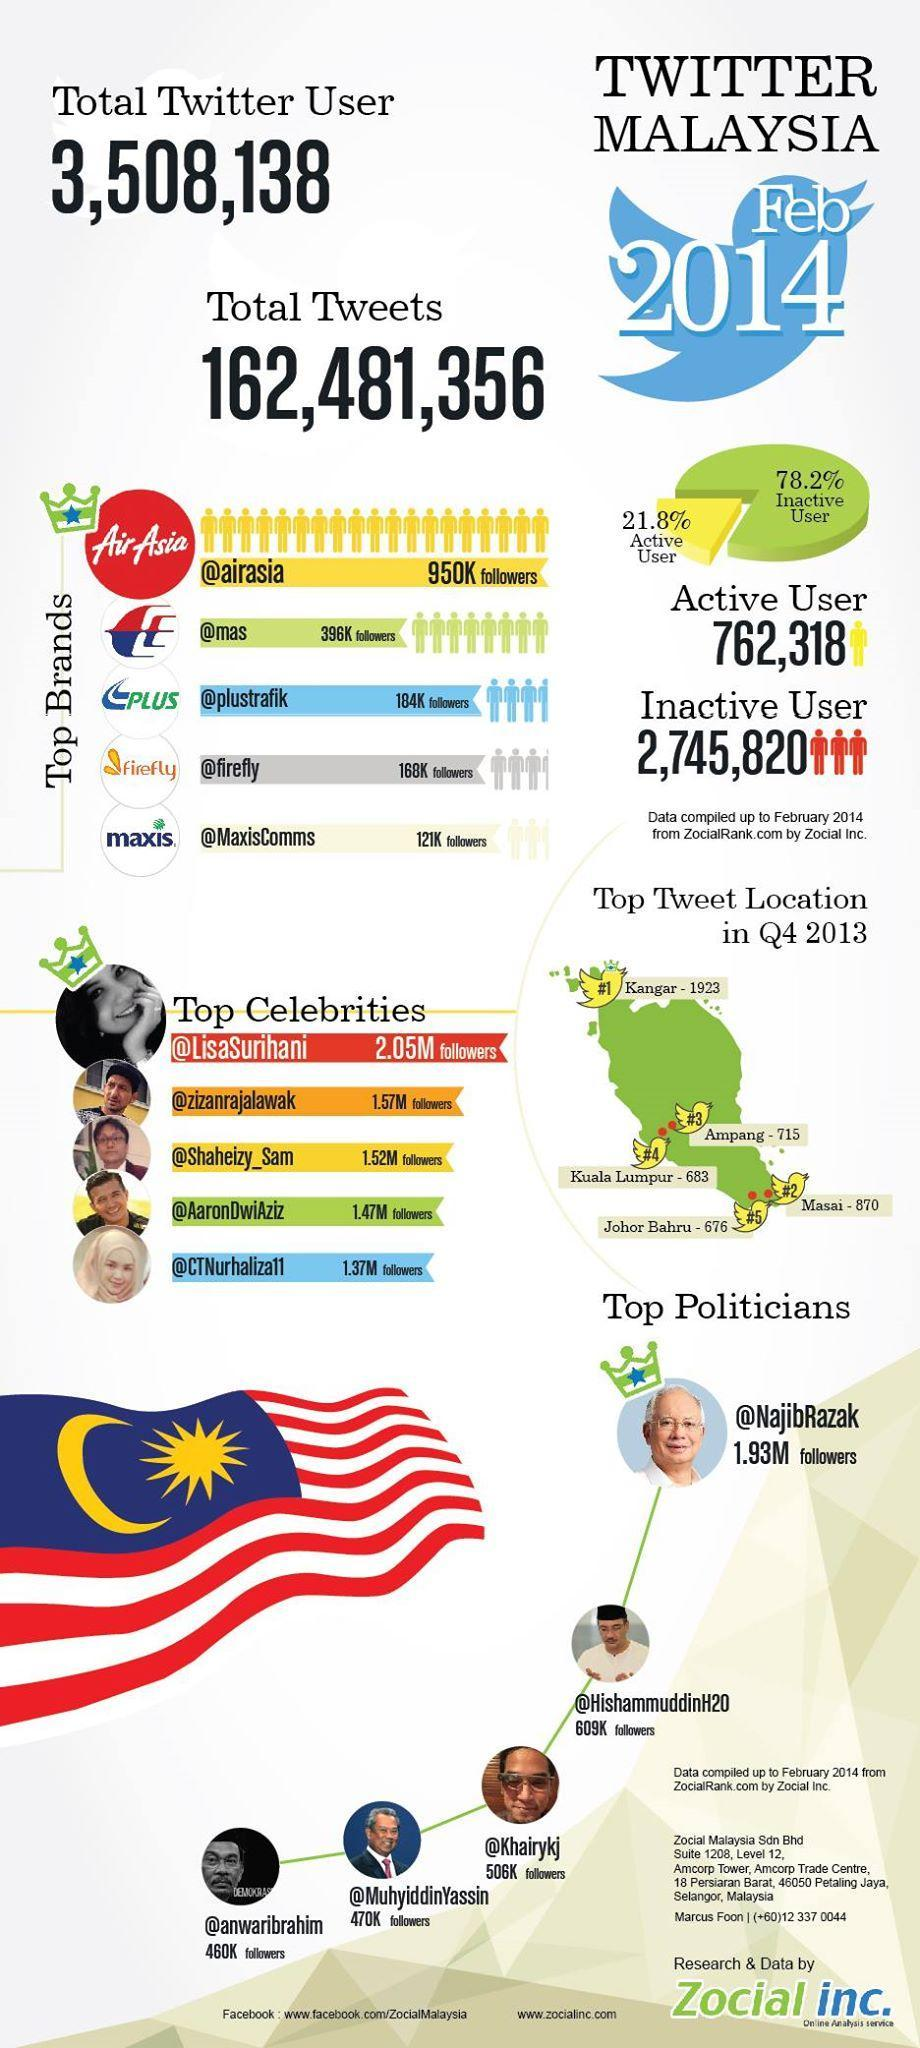How many million followers are there for the third-most celebrity in Malaysia?
Answer the question with a short phrase. 1.52 Which place in Malaysia received the second-least no: of tweets in 2013? Kuala Lumpur What number of Malaysians are regular Twitter users? 762,318 How many followers (thousands) are there for the fourth-most brand of Malaysia? 168K How many followers (thousands) are there for the third and fourth top politicians taken together? 976 What percentage of Malaysia uses Twitter often? 21.8% What number of Malaysians are Lazy Twitter users? 2,745,820 How many Twitter messages sent by Malaysian people in 2014? 162,481,356 Which color is the Regular Twitter Users- green, blue, yellow, red? yellow Which brand is the second-most favorite of Malaysian people? mas 